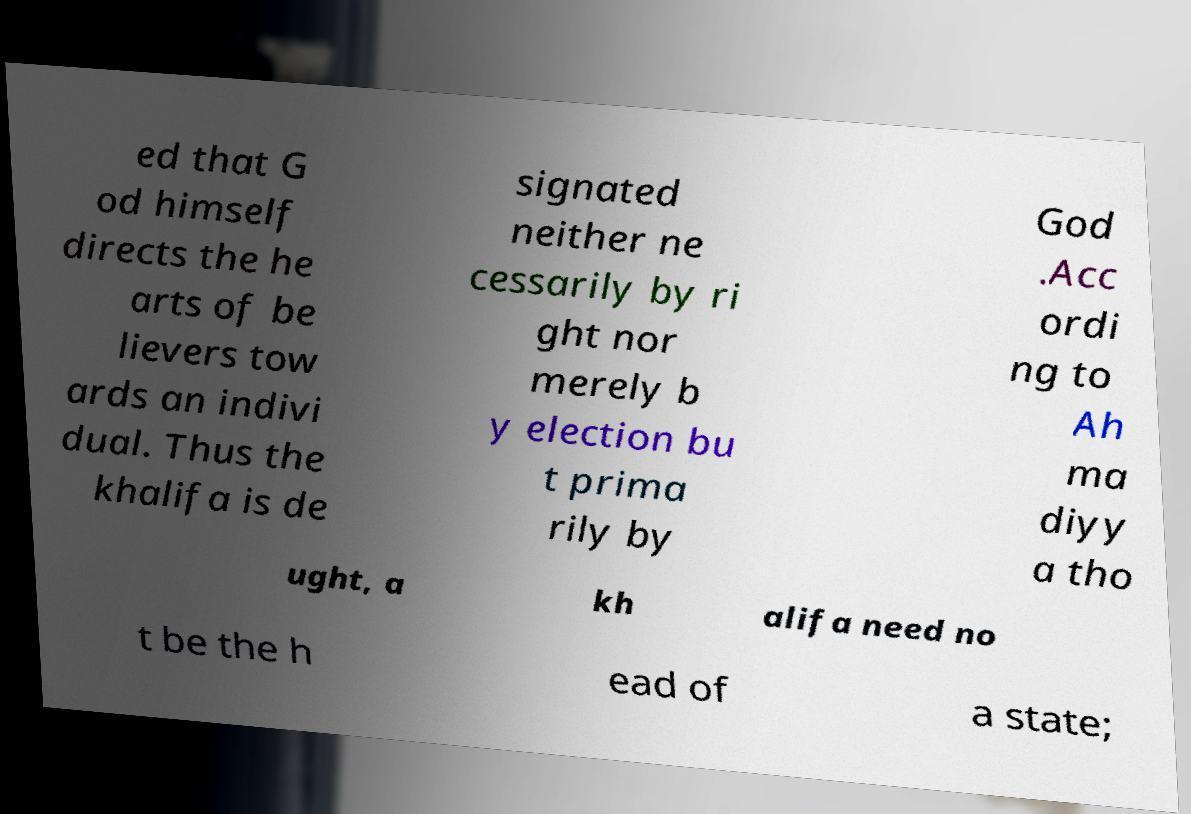Please identify and transcribe the text found in this image. ed that G od himself directs the he arts of be lievers tow ards an indivi dual. Thus the khalifa is de signated neither ne cessarily by ri ght nor merely b y election bu t prima rily by God .Acc ordi ng to Ah ma diyy a tho ught, a kh alifa need no t be the h ead of a state; 